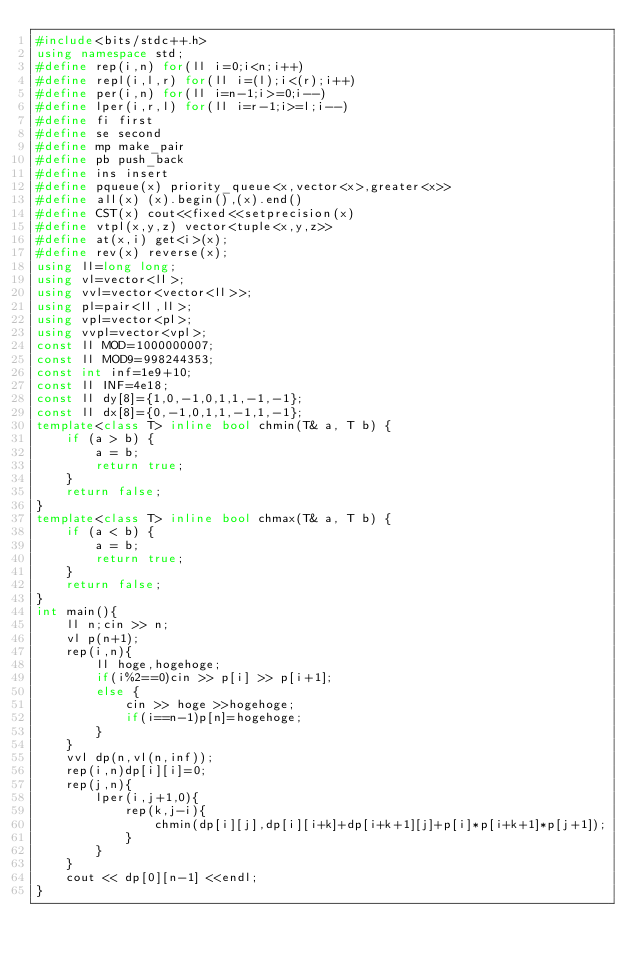<code> <loc_0><loc_0><loc_500><loc_500><_C++_>#include<bits/stdc++.h>
using namespace std;
#define rep(i,n) for(ll i=0;i<n;i++)
#define repl(i,l,r) for(ll i=(l);i<(r);i++)
#define per(i,n) for(ll i=n-1;i>=0;i--)
#define lper(i,r,l) for(ll i=r-1;i>=l;i--)
#define fi first
#define se second
#define mp make_pair
#define pb push_back
#define ins insert
#define pqueue(x) priority_queue<x,vector<x>,greater<x>>
#define all(x) (x).begin(),(x).end()
#define CST(x) cout<<fixed<<setprecision(x)
#define vtpl(x,y,z) vector<tuple<x,y,z>>
#define at(x,i) get<i>(x);
#define rev(x) reverse(x);
using ll=long long;
using vl=vector<ll>;
using vvl=vector<vector<ll>>;
using pl=pair<ll,ll>;
using vpl=vector<pl>;
using vvpl=vector<vpl>;
const ll MOD=1000000007;
const ll MOD9=998244353;
const int inf=1e9+10;
const ll INF=4e18;
const ll dy[8]={1,0,-1,0,1,1,-1,-1};
const ll dx[8]={0,-1,0,1,1,-1,1,-1};
template<class T> inline bool chmin(T& a, T b) {
    if (a > b) {
        a = b;
        return true;
    }
    return false;
}
template<class T> inline bool chmax(T& a, T b) {
    if (a < b) {
        a = b;
        return true;
    }
    return false;
}
int main(){
    ll n;cin >> n;
    vl p(n+1);
    rep(i,n){
        ll hoge,hogehoge;
        if(i%2==0)cin >> p[i] >> p[i+1];
        else {
            cin >> hoge >>hogehoge;
            if(i==n-1)p[n]=hogehoge;
        }
    }
    vvl dp(n,vl(n,inf));
    rep(i,n)dp[i][i]=0;
    rep(j,n){
        lper(i,j+1,0){
            rep(k,j-i){
                chmin(dp[i][j],dp[i][i+k]+dp[i+k+1][j]+p[i]*p[i+k+1]*p[j+1]);
            }
        }
    }
    cout << dp[0][n-1] <<endl;
}

</code> 